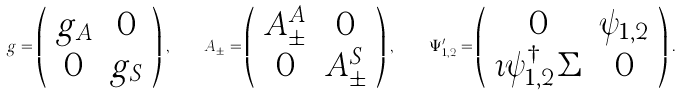Convert formula to latex. <formula><loc_0><loc_0><loc_500><loc_500>g = \left ( \begin{array} { c c } g _ { A } & 0 \\ 0 & g _ { S } \end{array} \right ) \, , \quad A _ { \pm } = \left ( \begin{array} { c c } A ^ { A } _ { \pm } & 0 \\ 0 & A ^ { S } _ { \pm } \end{array} \right ) \, , \quad \Psi ^ { \prime } _ { 1 , 2 } = \left ( \begin{array} { c c } 0 & \psi _ { 1 , 2 } \\ \imath \psi _ { 1 , 2 } ^ { \dagger } \Sigma & 0 \\ \end{array} \right ) \, .</formula> 